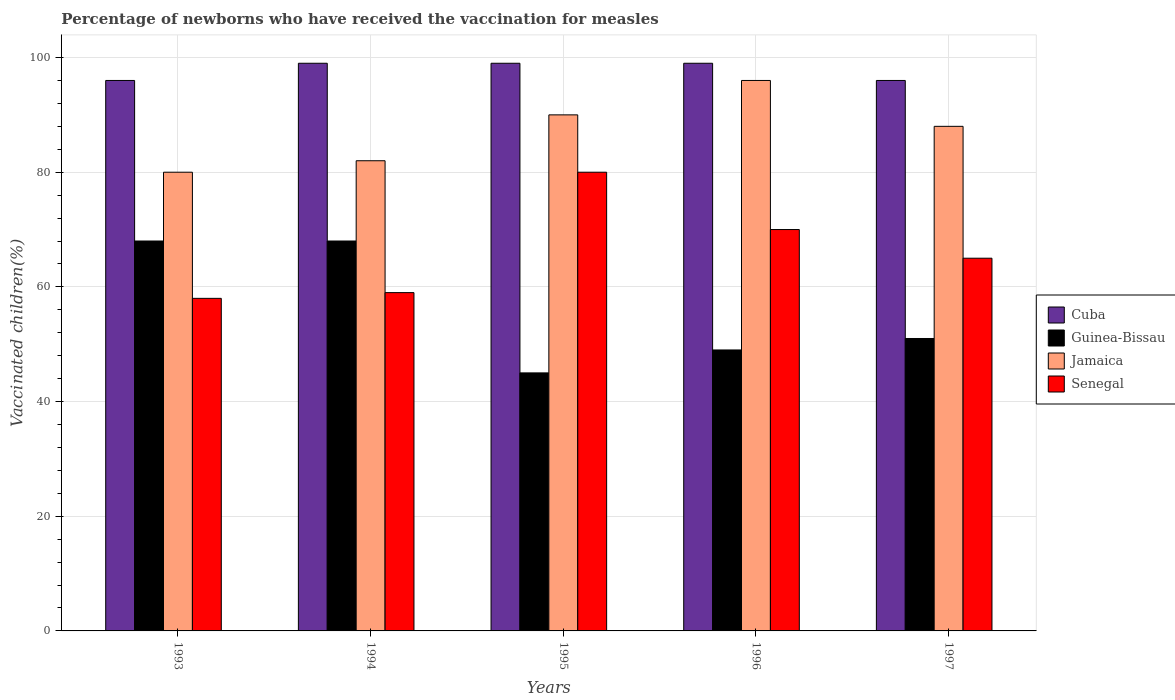How many different coloured bars are there?
Offer a terse response. 4. How many groups of bars are there?
Your response must be concise. 5. Are the number of bars per tick equal to the number of legend labels?
Your answer should be compact. Yes. How many bars are there on the 3rd tick from the left?
Provide a succinct answer. 4. What is the percentage of vaccinated children in Senegal in 1993?
Provide a succinct answer. 58. Across all years, what is the minimum percentage of vaccinated children in Cuba?
Make the answer very short. 96. What is the total percentage of vaccinated children in Cuba in the graph?
Your response must be concise. 489. What is the average percentage of vaccinated children in Cuba per year?
Offer a very short reply. 97.8. What is the ratio of the percentage of vaccinated children in Jamaica in 1993 to that in 1995?
Provide a succinct answer. 0.89. What is the difference between the highest and the lowest percentage of vaccinated children in Jamaica?
Your response must be concise. 16. Is the sum of the percentage of vaccinated children in Jamaica in 1995 and 1996 greater than the maximum percentage of vaccinated children in Cuba across all years?
Your response must be concise. Yes. Is it the case that in every year, the sum of the percentage of vaccinated children in Senegal and percentage of vaccinated children in Guinea-Bissau is greater than the sum of percentage of vaccinated children in Jamaica and percentage of vaccinated children in Cuba?
Your answer should be compact. No. What does the 1st bar from the left in 1994 represents?
Make the answer very short. Cuba. What does the 1st bar from the right in 1994 represents?
Your answer should be very brief. Senegal. Is it the case that in every year, the sum of the percentage of vaccinated children in Jamaica and percentage of vaccinated children in Guinea-Bissau is greater than the percentage of vaccinated children in Senegal?
Make the answer very short. Yes. How many bars are there?
Provide a succinct answer. 20. Are all the bars in the graph horizontal?
Your answer should be compact. No. What is the difference between two consecutive major ticks on the Y-axis?
Your answer should be compact. 20. Are the values on the major ticks of Y-axis written in scientific E-notation?
Offer a very short reply. No. Does the graph contain grids?
Ensure brevity in your answer.  Yes. Where does the legend appear in the graph?
Keep it short and to the point. Center right. How many legend labels are there?
Ensure brevity in your answer.  4. How are the legend labels stacked?
Offer a very short reply. Vertical. What is the title of the graph?
Your response must be concise. Percentage of newborns who have received the vaccination for measles. What is the label or title of the X-axis?
Keep it short and to the point. Years. What is the label or title of the Y-axis?
Make the answer very short. Vaccinated children(%). What is the Vaccinated children(%) in Cuba in 1993?
Offer a terse response. 96. What is the Vaccinated children(%) in Guinea-Bissau in 1993?
Give a very brief answer. 68. What is the Vaccinated children(%) in Jamaica in 1993?
Offer a terse response. 80. What is the Vaccinated children(%) of Cuba in 1994?
Offer a very short reply. 99. What is the Vaccinated children(%) in Senegal in 1994?
Provide a succinct answer. 59. What is the Vaccinated children(%) of Cuba in 1995?
Provide a short and direct response. 99. What is the Vaccinated children(%) in Jamaica in 1995?
Give a very brief answer. 90. What is the Vaccinated children(%) of Cuba in 1996?
Keep it short and to the point. 99. What is the Vaccinated children(%) of Jamaica in 1996?
Keep it short and to the point. 96. What is the Vaccinated children(%) of Cuba in 1997?
Your answer should be compact. 96. What is the Vaccinated children(%) of Guinea-Bissau in 1997?
Your answer should be compact. 51. What is the Vaccinated children(%) in Senegal in 1997?
Keep it short and to the point. 65. Across all years, what is the maximum Vaccinated children(%) in Cuba?
Make the answer very short. 99. Across all years, what is the maximum Vaccinated children(%) of Jamaica?
Provide a succinct answer. 96. Across all years, what is the maximum Vaccinated children(%) in Senegal?
Your answer should be very brief. 80. Across all years, what is the minimum Vaccinated children(%) in Cuba?
Give a very brief answer. 96. Across all years, what is the minimum Vaccinated children(%) of Jamaica?
Your response must be concise. 80. What is the total Vaccinated children(%) in Cuba in the graph?
Ensure brevity in your answer.  489. What is the total Vaccinated children(%) of Guinea-Bissau in the graph?
Your answer should be compact. 281. What is the total Vaccinated children(%) of Jamaica in the graph?
Make the answer very short. 436. What is the total Vaccinated children(%) of Senegal in the graph?
Provide a short and direct response. 332. What is the difference between the Vaccinated children(%) in Senegal in 1993 and that in 1994?
Your response must be concise. -1. What is the difference between the Vaccinated children(%) of Guinea-Bissau in 1993 and that in 1995?
Offer a very short reply. 23. What is the difference between the Vaccinated children(%) of Jamaica in 1993 and that in 1995?
Ensure brevity in your answer.  -10. What is the difference between the Vaccinated children(%) in Jamaica in 1993 and that in 1996?
Give a very brief answer. -16. What is the difference between the Vaccinated children(%) of Senegal in 1993 and that in 1996?
Your response must be concise. -12. What is the difference between the Vaccinated children(%) of Guinea-Bissau in 1993 and that in 1997?
Offer a very short reply. 17. What is the difference between the Vaccinated children(%) of Jamaica in 1993 and that in 1997?
Offer a very short reply. -8. What is the difference between the Vaccinated children(%) of Cuba in 1994 and that in 1995?
Keep it short and to the point. 0. What is the difference between the Vaccinated children(%) in Guinea-Bissau in 1994 and that in 1995?
Your response must be concise. 23. What is the difference between the Vaccinated children(%) in Jamaica in 1994 and that in 1995?
Provide a short and direct response. -8. What is the difference between the Vaccinated children(%) of Cuba in 1994 and that in 1996?
Your response must be concise. 0. What is the difference between the Vaccinated children(%) in Guinea-Bissau in 1994 and that in 1996?
Your answer should be very brief. 19. What is the difference between the Vaccinated children(%) in Jamaica in 1994 and that in 1996?
Offer a very short reply. -14. What is the difference between the Vaccinated children(%) of Senegal in 1994 and that in 1996?
Your answer should be compact. -11. What is the difference between the Vaccinated children(%) of Senegal in 1995 and that in 1996?
Your answer should be very brief. 10. What is the difference between the Vaccinated children(%) of Cuba in 1995 and that in 1997?
Make the answer very short. 3. What is the difference between the Vaccinated children(%) of Jamaica in 1995 and that in 1997?
Offer a terse response. 2. What is the difference between the Vaccinated children(%) in Cuba in 1996 and that in 1997?
Give a very brief answer. 3. What is the difference between the Vaccinated children(%) in Guinea-Bissau in 1996 and that in 1997?
Your answer should be very brief. -2. What is the difference between the Vaccinated children(%) in Cuba in 1993 and the Vaccinated children(%) in Guinea-Bissau in 1994?
Ensure brevity in your answer.  28. What is the difference between the Vaccinated children(%) of Cuba in 1993 and the Vaccinated children(%) of Senegal in 1994?
Keep it short and to the point. 37. What is the difference between the Vaccinated children(%) in Guinea-Bissau in 1993 and the Vaccinated children(%) in Jamaica in 1994?
Offer a very short reply. -14. What is the difference between the Vaccinated children(%) of Guinea-Bissau in 1993 and the Vaccinated children(%) of Senegal in 1994?
Keep it short and to the point. 9. What is the difference between the Vaccinated children(%) of Jamaica in 1993 and the Vaccinated children(%) of Senegal in 1994?
Ensure brevity in your answer.  21. What is the difference between the Vaccinated children(%) in Cuba in 1993 and the Vaccinated children(%) in Guinea-Bissau in 1995?
Your answer should be compact. 51. What is the difference between the Vaccinated children(%) of Cuba in 1993 and the Vaccinated children(%) of Senegal in 1995?
Your response must be concise. 16. What is the difference between the Vaccinated children(%) of Guinea-Bissau in 1993 and the Vaccinated children(%) of Jamaica in 1995?
Provide a succinct answer. -22. What is the difference between the Vaccinated children(%) in Cuba in 1993 and the Vaccinated children(%) in Jamaica in 1996?
Give a very brief answer. 0. What is the difference between the Vaccinated children(%) in Cuba in 1993 and the Vaccinated children(%) in Senegal in 1996?
Keep it short and to the point. 26. What is the difference between the Vaccinated children(%) in Guinea-Bissau in 1993 and the Vaccinated children(%) in Jamaica in 1996?
Give a very brief answer. -28. What is the difference between the Vaccinated children(%) in Cuba in 1993 and the Vaccinated children(%) in Jamaica in 1997?
Offer a very short reply. 8. What is the difference between the Vaccinated children(%) in Cuba in 1993 and the Vaccinated children(%) in Senegal in 1997?
Offer a terse response. 31. What is the difference between the Vaccinated children(%) in Guinea-Bissau in 1993 and the Vaccinated children(%) in Jamaica in 1997?
Keep it short and to the point. -20. What is the difference between the Vaccinated children(%) of Guinea-Bissau in 1993 and the Vaccinated children(%) of Senegal in 1997?
Ensure brevity in your answer.  3. What is the difference between the Vaccinated children(%) of Jamaica in 1993 and the Vaccinated children(%) of Senegal in 1997?
Make the answer very short. 15. What is the difference between the Vaccinated children(%) in Cuba in 1994 and the Vaccinated children(%) in Guinea-Bissau in 1995?
Provide a short and direct response. 54. What is the difference between the Vaccinated children(%) of Guinea-Bissau in 1994 and the Vaccinated children(%) of Jamaica in 1995?
Your answer should be very brief. -22. What is the difference between the Vaccinated children(%) of Guinea-Bissau in 1994 and the Vaccinated children(%) of Senegal in 1995?
Provide a short and direct response. -12. What is the difference between the Vaccinated children(%) in Guinea-Bissau in 1994 and the Vaccinated children(%) in Jamaica in 1996?
Offer a terse response. -28. What is the difference between the Vaccinated children(%) of Jamaica in 1994 and the Vaccinated children(%) of Senegal in 1996?
Make the answer very short. 12. What is the difference between the Vaccinated children(%) of Cuba in 1994 and the Vaccinated children(%) of Guinea-Bissau in 1997?
Give a very brief answer. 48. What is the difference between the Vaccinated children(%) in Cuba in 1994 and the Vaccinated children(%) in Senegal in 1997?
Your response must be concise. 34. What is the difference between the Vaccinated children(%) of Guinea-Bissau in 1994 and the Vaccinated children(%) of Senegal in 1997?
Make the answer very short. 3. What is the difference between the Vaccinated children(%) in Cuba in 1995 and the Vaccinated children(%) in Guinea-Bissau in 1996?
Offer a very short reply. 50. What is the difference between the Vaccinated children(%) of Cuba in 1995 and the Vaccinated children(%) of Jamaica in 1996?
Provide a short and direct response. 3. What is the difference between the Vaccinated children(%) of Guinea-Bissau in 1995 and the Vaccinated children(%) of Jamaica in 1996?
Give a very brief answer. -51. What is the difference between the Vaccinated children(%) of Guinea-Bissau in 1995 and the Vaccinated children(%) of Senegal in 1996?
Your response must be concise. -25. What is the difference between the Vaccinated children(%) in Cuba in 1995 and the Vaccinated children(%) in Senegal in 1997?
Provide a short and direct response. 34. What is the difference between the Vaccinated children(%) of Guinea-Bissau in 1995 and the Vaccinated children(%) of Jamaica in 1997?
Offer a terse response. -43. What is the difference between the Vaccinated children(%) in Guinea-Bissau in 1995 and the Vaccinated children(%) in Senegal in 1997?
Your answer should be compact. -20. What is the difference between the Vaccinated children(%) in Cuba in 1996 and the Vaccinated children(%) in Jamaica in 1997?
Provide a short and direct response. 11. What is the difference between the Vaccinated children(%) of Guinea-Bissau in 1996 and the Vaccinated children(%) of Jamaica in 1997?
Provide a succinct answer. -39. What is the difference between the Vaccinated children(%) of Guinea-Bissau in 1996 and the Vaccinated children(%) of Senegal in 1997?
Offer a very short reply. -16. What is the difference between the Vaccinated children(%) of Jamaica in 1996 and the Vaccinated children(%) of Senegal in 1997?
Ensure brevity in your answer.  31. What is the average Vaccinated children(%) of Cuba per year?
Provide a short and direct response. 97.8. What is the average Vaccinated children(%) of Guinea-Bissau per year?
Provide a succinct answer. 56.2. What is the average Vaccinated children(%) of Jamaica per year?
Your answer should be very brief. 87.2. What is the average Vaccinated children(%) of Senegal per year?
Offer a very short reply. 66.4. In the year 1993, what is the difference between the Vaccinated children(%) of Jamaica and Vaccinated children(%) of Senegal?
Your answer should be compact. 22. In the year 1994, what is the difference between the Vaccinated children(%) of Cuba and Vaccinated children(%) of Senegal?
Your response must be concise. 40. In the year 1994, what is the difference between the Vaccinated children(%) in Guinea-Bissau and Vaccinated children(%) in Jamaica?
Your answer should be very brief. -14. In the year 1994, what is the difference between the Vaccinated children(%) in Jamaica and Vaccinated children(%) in Senegal?
Make the answer very short. 23. In the year 1995, what is the difference between the Vaccinated children(%) of Cuba and Vaccinated children(%) of Jamaica?
Ensure brevity in your answer.  9. In the year 1995, what is the difference between the Vaccinated children(%) in Cuba and Vaccinated children(%) in Senegal?
Provide a succinct answer. 19. In the year 1995, what is the difference between the Vaccinated children(%) in Guinea-Bissau and Vaccinated children(%) in Jamaica?
Give a very brief answer. -45. In the year 1995, what is the difference between the Vaccinated children(%) of Guinea-Bissau and Vaccinated children(%) of Senegal?
Your response must be concise. -35. In the year 1995, what is the difference between the Vaccinated children(%) in Jamaica and Vaccinated children(%) in Senegal?
Provide a succinct answer. 10. In the year 1996, what is the difference between the Vaccinated children(%) in Cuba and Vaccinated children(%) in Jamaica?
Provide a short and direct response. 3. In the year 1996, what is the difference between the Vaccinated children(%) of Cuba and Vaccinated children(%) of Senegal?
Your response must be concise. 29. In the year 1996, what is the difference between the Vaccinated children(%) in Guinea-Bissau and Vaccinated children(%) in Jamaica?
Give a very brief answer. -47. In the year 1996, what is the difference between the Vaccinated children(%) in Guinea-Bissau and Vaccinated children(%) in Senegal?
Provide a succinct answer. -21. In the year 1996, what is the difference between the Vaccinated children(%) in Jamaica and Vaccinated children(%) in Senegal?
Provide a short and direct response. 26. In the year 1997, what is the difference between the Vaccinated children(%) in Guinea-Bissau and Vaccinated children(%) in Jamaica?
Offer a terse response. -37. In the year 1997, what is the difference between the Vaccinated children(%) of Guinea-Bissau and Vaccinated children(%) of Senegal?
Provide a succinct answer. -14. In the year 1997, what is the difference between the Vaccinated children(%) in Jamaica and Vaccinated children(%) in Senegal?
Ensure brevity in your answer.  23. What is the ratio of the Vaccinated children(%) of Cuba in 1993 to that in 1994?
Your answer should be compact. 0.97. What is the ratio of the Vaccinated children(%) of Guinea-Bissau in 1993 to that in 1994?
Your response must be concise. 1. What is the ratio of the Vaccinated children(%) of Jamaica in 1993 to that in 1994?
Offer a very short reply. 0.98. What is the ratio of the Vaccinated children(%) in Senegal in 1993 to that in 1994?
Your answer should be compact. 0.98. What is the ratio of the Vaccinated children(%) in Cuba in 1993 to that in 1995?
Make the answer very short. 0.97. What is the ratio of the Vaccinated children(%) of Guinea-Bissau in 1993 to that in 1995?
Your answer should be very brief. 1.51. What is the ratio of the Vaccinated children(%) in Senegal in 1993 to that in 1995?
Provide a succinct answer. 0.72. What is the ratio of the Vaccinated children(%) in Cuba in 1993 to that in 1996?
Give a very brief answer. 0.97. What is the ratio of the Vaccinated children(%) in Guinea-Bissau in 1993 to that in 1996?
Offer a very short reply. 1.39. What is the ratio of the Vaccinated children(%) of Senegal in 1993 to that in 1996?
Ensure brevity in your answer.  0.83. What is the ratio of the Vaccinated children(%) in Guinea-Bissau in 1993 to that in 1997?
Your answer should be very brief. 1.33. What is the ratio of the Vaccinated children(%) in Jamaica in 1993 to that in 1997?
Provide a short and direct response. 0.91. What is the ratio of the Vaccinated children(%) in Senegal in 1993 to that in 1997?
Your answer should be compact. 0.89. What is the ratio of the Vaccinated children(%) of Cuba in 1994 to that in 1995?
Offer a terse response. 1. What is the ratio of the Vaccinated children(%) in Guinea-Bissau in 1994 to that in 1995?
Your answer should be very brief. 1.51. What is the ratio of the Vaccinated children(%) of Jamaica in 1994 to that in 1995?
Your response must be concise. 0.91. What is the ratio of the Vaccinated children(%) in Senegal in 1994 to that in 1995?
Your response must be concise. 0.74. What is the ratio of the Vaccinated children(%) of Guinea-Bissau in 1994 to that in 1996?
Make the answer very short. 1.39. What is the ratio of the Vaccinated children(%) in Jamaica in 1994 to that in 1996?
Your response must be concise. 0.85. What is the ratio of the Vaccinated children(%) in Senegal in 1994 to that in 1996?
Give a very brief answer. 0.84. What is the ratio of the Vaccinated children(%) of Cuba in 1994 to that in 1997?
Offer a terse response. 1.03. What is the ratio of the Vaccinated children(%) of Jamaica in 1994 to that in 1997?
Your response must be concise. 0.93. What is the ratio of the Vaccinated children(%) of Senegal in 1994 to that in 1997?
Give a very brief answer. 0.91. What is the ratio of the Vaccinated children(%) in Cuba in 1995 to that in 1996?
Your response must be concise. 1. What is the ratio of the Vaccinated children(%) in Guinea-Bissau in 1995 to that in 1996?
Your response must be concise. 0.92. What is the ratio of the Vaccinated children(%) of Jamaica in 1995 to that in 1996?
Ensure brevity in your answer.  0.94. What is the ratio of the Vaccinated children(%) of Senegal in 1995 to that in 1996?
Your answer should be compact. 1.14. What is the ratio of the Vaccinated children(%) of Cuba in 1995 to that in 1997?
Your answer should be compact. 1.03. What is the ratio of the Vaccinated children(%) of Guinea-Bissau in 1995 to that in 1997?
Ensure brevity in your answer.  0.88. What is the ratio of the Vaccinated children(%) of Jamaica in 1995 to that in 1997?
Keep it short and to the point. 1.02. What is the ratio of the Vaccinated children(%) in Senegal in 1995 to that in 1997?
Keep it short and to the point. 1.23. What is the ratio of the Vaccinated children(%) of Cuba in 1996 to that in 1997?
Ensure brevity in your answer.  1.03. What is the ratio of the Vaccinated children(%) in Guinea-Bissau in 1996 to that in 1997?
Offer a terse response. 0.96. What is the ratio of the Vaccinated children(%) in Jamaica in 1996 to that in 1997?
Your answer should be very brief. 1.09. What is the difference between the highest and the second highest Vaccinated children(%) of Guinea-Bissau?
Your response must be concise. 0. What is the difference between the highest and the second highest Vaccinated children(%) in Jamaica?
Offer a very short reply. 6. What is the difference between the highest and the second highest Vaccinated children(%) in Senegal?
Your answer should be very brief. 10. What is the difference between the highest and the lowest Vaccinated children(%) of Cuba?
Provide a short and direct response. 3. What is the difference between the highest and the lowest Vaccinated children(%) of Guinea-Bissau?
Give a very brief answer. 23. What is the difference between the highest and the lowest Vaccinated children(%) in Jamaica?
Ensure brevity in your answer.  16. 